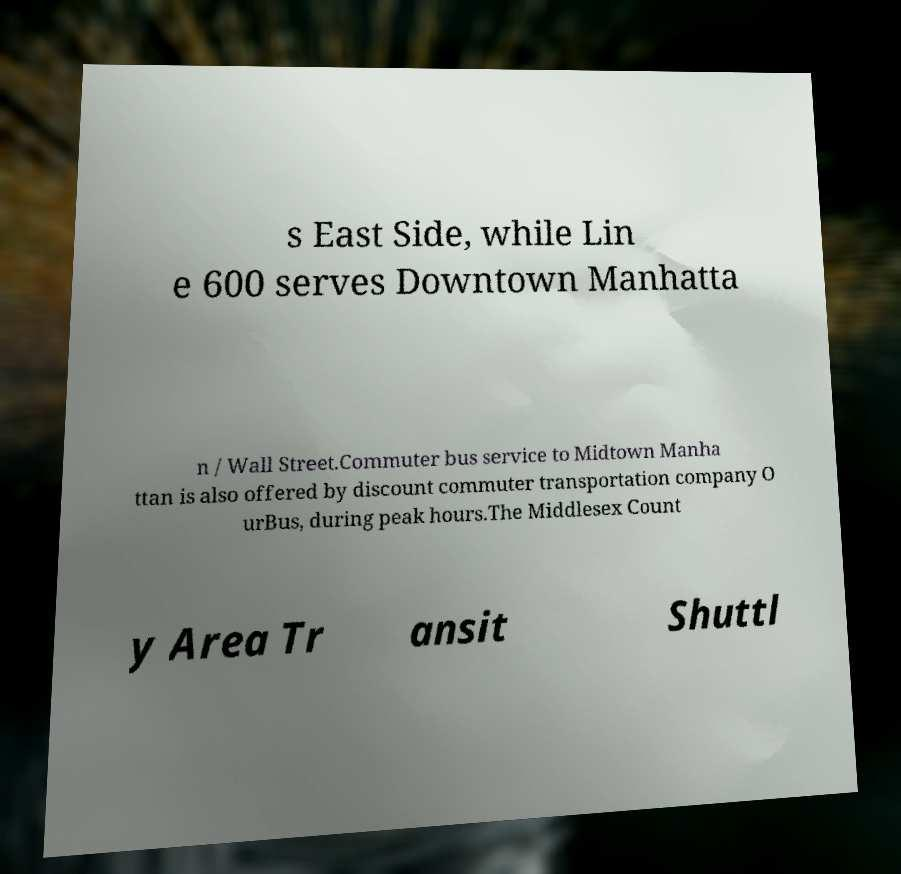Please read and relay the text visible in this image. What does it say? s East Side, while Lin e 600 serves Downtown Manhatta n / Wall Street.Commuter bus service to Midtown Manha ttan is also offered by discount commuter transportation company O urBus, during peak hours.The Middlesex Count y Area Tr ansit Shuttl 